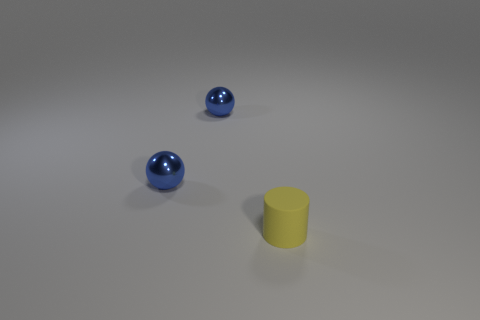Add 1 small blue metal balls. How many objects exist? 4 Subtract all cylinders. How many objects are left? 2 Add 1 tiny rubber cylinders. How many tiny rubber cylinders exist? 2 Subtract 0 red blocks. How many objects are left? 3 Subtract all tiny yellow rubber objects. Subtract all yellow objects. How many objects are left? 1 Add 2 tiny balls. How many tiny balls are left? 4 